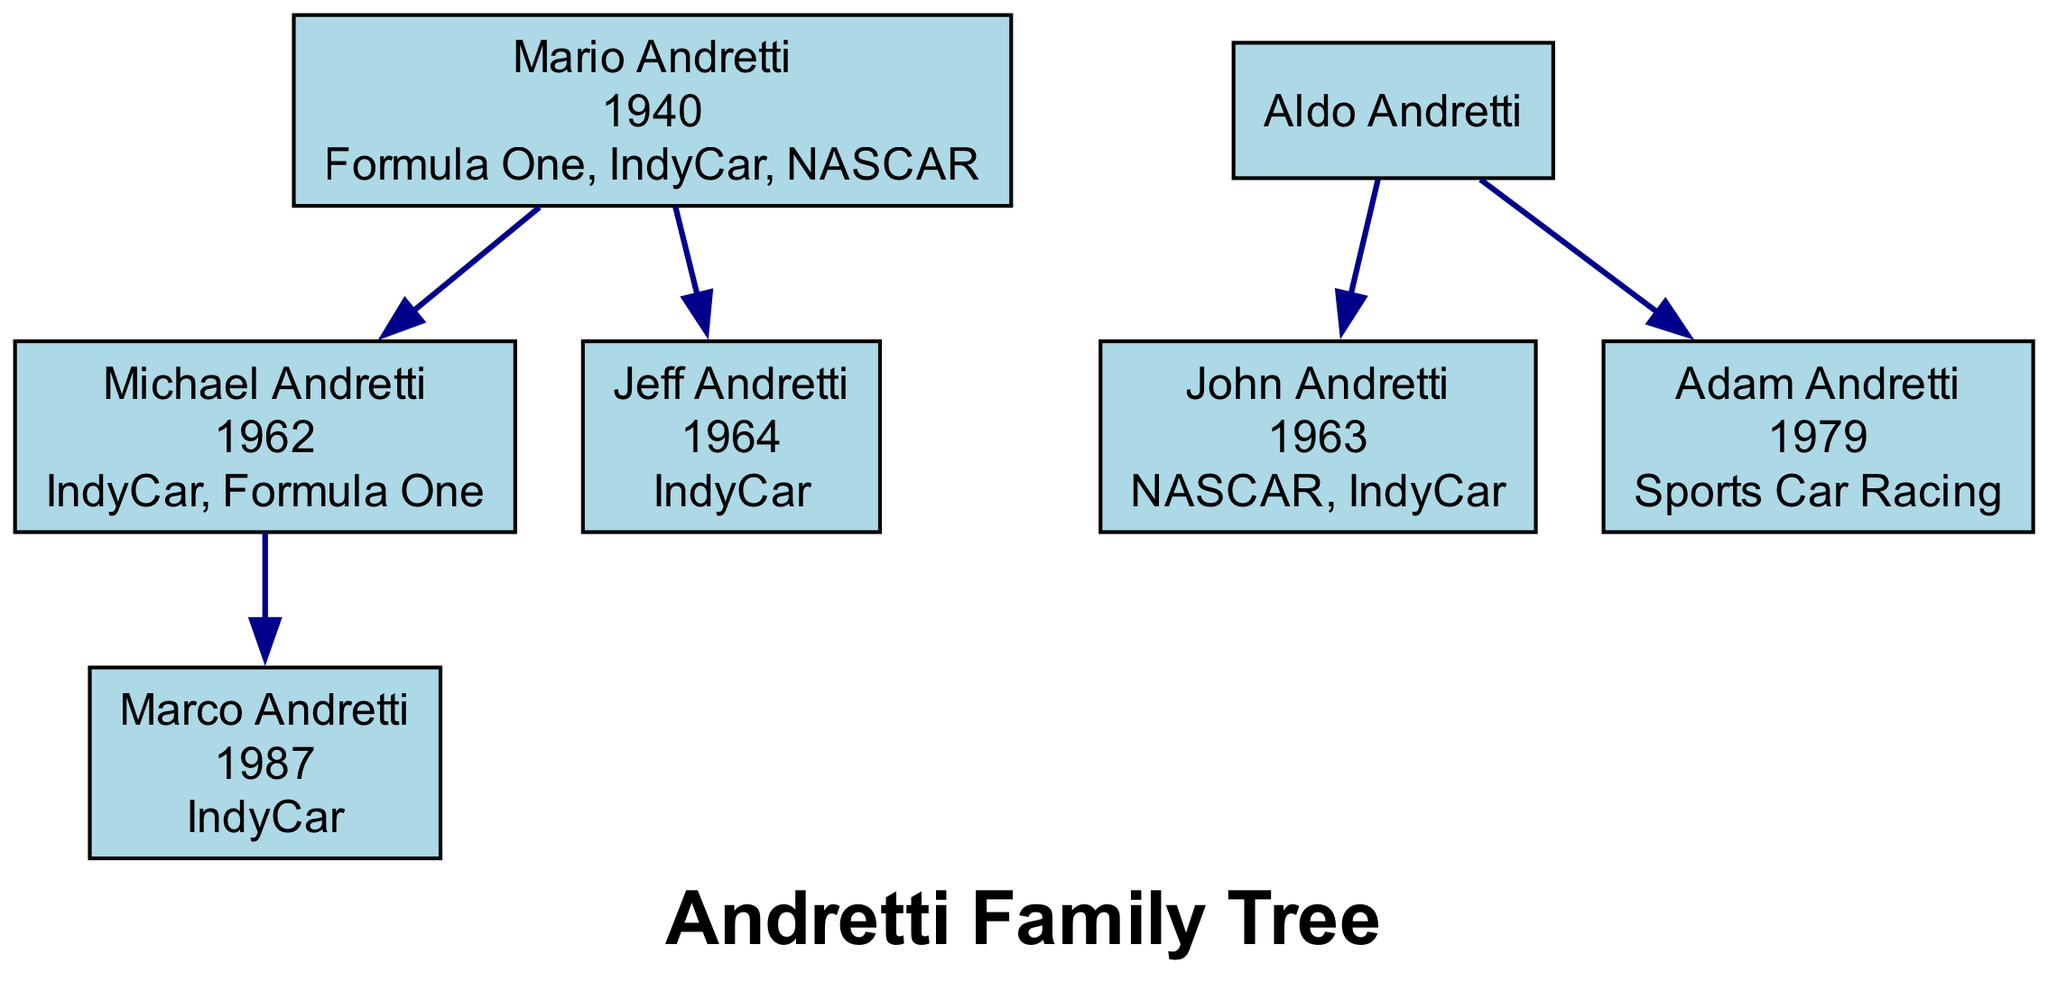What racing discipline did Mario Andretti participate in? The diagram lists "Formula One," "IndyCar," and "NASCAR" under Mario Andretti, indicating his involvement in all three racing disciplines.
Answer: Formula One, IndyCar, NASCAR How many generations of the Andretti family are involved in racing? The diagram shows six individuals, which represents three generations with Mario Andretti as the patriarch.
Answer: Three Who is the child of Michael Andretti? By reviewing the node for Michael Andretti, we see that Marco Andretti is connected as his child in the diagram.
Answer: Marco Andretti Which racing discipline is associated with Adam Andretti? The diagram indicates that Adam Andretti is involved in "Sports Car Racing," providing a direct connection to that discipline.
Answer: Sports Car Racing Which family member is connected to both NASCAR and IndyCar? The diagram shows John Andretti is linked to both disciplines, making him the relevant family member.
Answer: John Andretti What is the birth year of Jeff Andretti? By checking the information associated with Jeff Andretti in the diagram, we find that his birth year is clearly listed as 1964.
Answer: 1964 How many individuals in the family tree are involved in IndyCar racing? Examining the nodes in the diagram for alignment with IndyCar, there are four individuals: Mario, Michael, Jeff, and Marco.
Answer: Four Which two individuals are siblings on the diagram? The diagram connects Jeff Andretti and Michael Andretti to Mario, indicating they are siblings as both share the same parent.
Answer: Jeff Andretti, Michael Andretti Who is the parent of Adam Andretti? By looking at the node for Adam Andretti, it specifies that he is the child of Aldo Andretti within the structure of the family tree.
Answer: Aldo Andretti 